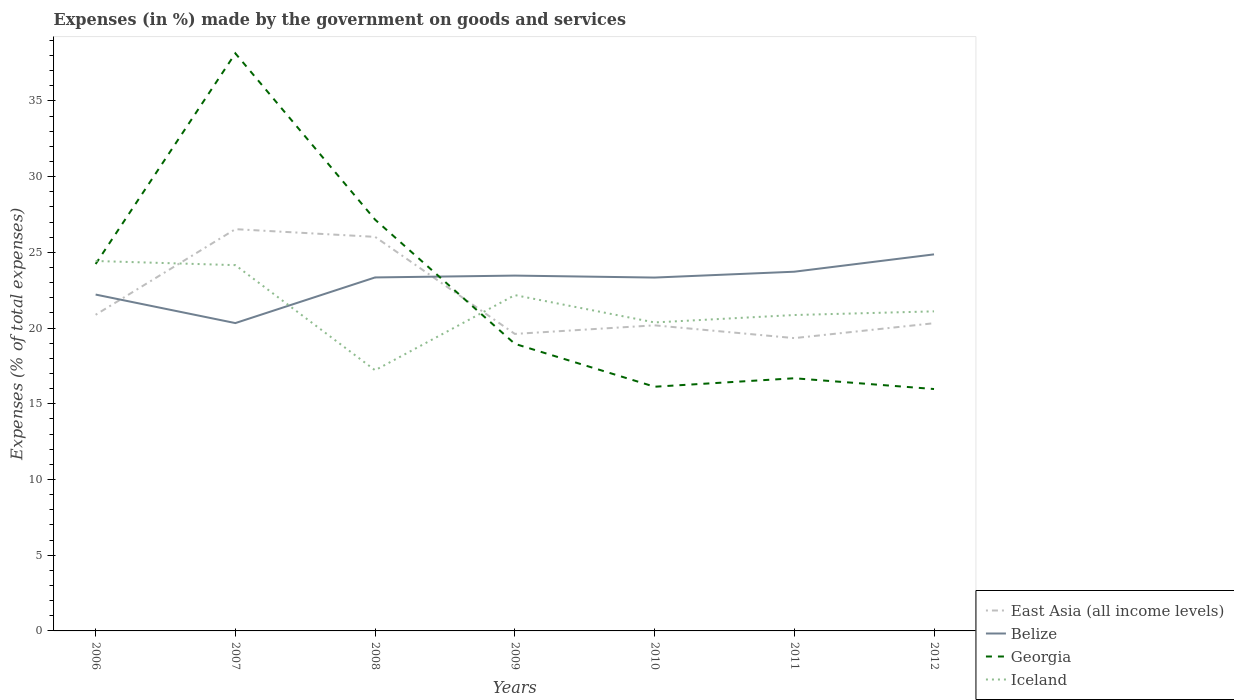How many different coloured lines are there?
Provide a short and direct response. 4. Is the number of lines equal to the number of legend labels?
Your answer should be very brief. Yes. Across all years, what is the maximum percentage of expenses made by the government on goods and services in East Asia (all income levels)?
Offer a terse response. 19.34. In which year was the percentage of expenses made by the government on goods and services in Georgia maximum?
Ensure brevity in your answer.  2012. What is the total percentage of expenses made by the government on goods and services in Belize in the graph?
Your answer should be very brief. -1.51. What is the difference between the highest and the second highest percentage of expenses made by the government on goods and services in East Asia (all income levels)?
Offer a terse response. 7.19. Is the percentage of expenses made by the government on goods and services in Iceland strictly greater than the percentage of expenses made by the government on goods and services in Georgia over the years?
Your response must be concise. No. How many lines are there?
Provide a short and direct response. 4. What is the difference between two consecutive major ticks on the Y-axis?
Keep it short and to the point. 5. Does the graph contain any zero values?
Ensure brevity in your answer.  No. Where does the legend appear in the graph?
Ensure brevity in your answer.  Bottom right. How many legend labels are there?
Your response must be concise. 4. What is the title of the graph?
Offer a terse response. Expenses (in %) made by the government on goods and services. Does "Antigua and Barbuda" appear as one of the legend labels in the graph?
Your answer should be very brief. No. What is the label or title of the Y-axis?
Keep it short and to the point. Expenses (% of total expenses). What is the Expenses (% of total expenses) in East Asia (all income levels) in 2006?
Provide a succinct answer. 20.88. What is the Expenses (% of total expenses) of Belize in 2006?
Your answer should be compact. 22.21. What is the Expenses (% of total expenses) of Georgia in 2006?
Provide a short and direct response. 24.23. What is the Expenses (% of total expenses) of Iceland in 2006?
Your answer should be very brief. 24.43. What is the Expenses (% of total expenses) in East Asia (all income levels) in 2007?
Your answer should be very brief. 26.53. What is the Expenses (% of total expenses) of Belize in 2007?
Your response must be concise. 20.33. What is the Expenses (% of total expenses) in Georgia in 2007?
Provide a succinct answer. 38.14. What is the Expenses (% of total expenses) of Iceland in 2007?
Offer a very short reply. 24.16. What is the Expenses (% of total expenses) in East Asia (all income levels) in 2008?
Ensure brevity in your answer.  26.02. What is the Expenses (% of total expenses) in Belize in 2008?
Your response must be concise. 23.35. What is the Expenses (% of total expenses) in Georgia in 2008?
Offer a very short reply. 27.16. What is the Expenses (% of total expenses) in Iceland in 2008?
Keep it short and to the point. 17.22. What is the Expenses (% of total expenses) of East Asia (all income levels) in 2009?
Make the answer very short. 19.62. What is the Expenses (% of total expenses) of Belize in 2009?
Your response must be concise. 23.47. What is the Expenses (% of total expenses) of Georgia in 2009?
Offer a very short reply. 18.96. What is the Expenses (% of total expenses) of Iceland in 2009?
Provide a short and direct response. 22.18. What is the Expenses (% of total expenses) in East Asia (all income levels) in 2010?
Your answer should be very brief. 20.18. What is the Expenses (% of total expenses) in Belize in 2010?
Provide a succinct answer. 23.34. What is the Expenses (% of total expenses) of Georgia in 2010?
Offer a very short reply. 16.13. What is the Expenses (% of total expenses) of Iceland in 2010?
Give a very brief answer. 20.37. What is the Expenses (% of total expenses) of East Asia (all income levels) in 2011?
Make the answer very short. 19.34. What is the Expenses (% of total expenses) in Belize in 2011?
Offer a very short reply. 23.72. What is the Expenses (% of total expenses) of Georgia in 2011?
Your answer should be compact. 16.69. What is the Expenses (% of total expenses) of Iceland in 2011?
Ensure brevity in your answer.  20.86. What is the Expenses (% of total expenses) of East Asia (all income levels) in 2012?
Your response must be concise. 20.32. What is the Expenses (% of total expenses) in Belize in 2012?
Give a very brief answer. 24.87. What is the Expenses (% of total expenses) in Georgia in 2012?
Your response must be concise. 15.98. What is the Expenses (% of total expenses) in Iceland in 2012?
Your answer should be compact. 21.11. Across all years, what is the maximum Expenses (% of total expenses) in East Asia (all income levels)?
Offer a very short reply. 26.53. Across all years, what is the maximum Expenses (% of total expenses) of Belize?
Your answer should be very brief. 24.87. Across all years, what is the maximum Expenses (% of total expenses) in Georgia?
Offer a terse response. 38.14. Across all years, what is the maximum Expenses (% of total expenses) of Iceland?
Your response must be concise. 24.43. Across all years, what is the minimum Expenses (% of total expenses) in East Asia (all income levels)?
Provide a short and direct response. 19.34. Across all years, what is the minimum Expenses (% of total expenses) in Belize?
Make the answer very short. 20.33. Across all years, what is the minimum Expenses (% of total expenses) in Georgia?
Offer a very short reply. 15.98. Across all years, what is the minimum Expenses (% of total expenses) of Iceland?
Offer a very short reply. 17.22. What is the total Expenses (% of total expenses) of East Asia (all income levels) in the graph?
Your answer should be compact. 152.89. What is the total Expenses (% of total expenses) in Belize in the graph?
Keep it short and to the point. 161.28. What is the total Expenses (% of total expenses) in Georgia in the graph?
Keep it short and to the point. 157.29. What is the total Expenses (% of total expenses) of Iceland in the graph?
Give a very brief answer. 150.32. What is the difference between the Expenses (% of total expenses) in East Asia (all income levels) in 2006 and that in 2007?
Offer a terse response. -5.65. What is the difference between the Expenses (% of total expenses) in Belize in 2006 and that in 2007?
Your answer should be very brief. 1.88. What is the difference between the Expenses (% of total expenses) in Georgia in 2006 and that in 2007?
Your response must be concise. -13.91. What is the difference between the Expenses (% of total expenses) in Iceland in 2006 and that in 2007?
Provide a succinct answer. 0.27. What is the difference between the Expenses (% of total expenses) of East Asia (all income levels) in 2006 and that in 2008?
Provide a short and direct response. -5.15. What is the difference between the Expenses (% of total expenses) in Belize in 2006 and that in 2008?
Offer a terse response. -1.13. What is the difference between the Expenses (% of total expenses) in Georgia in 2006 and that in 2008?
Provide a succinct answer. -2.93. What is the difference between the Expenses (% of total expenses) in Iceland in 2006 and that in 2008?
Offer a very short reply. 7.22. What is the difference between the Expenses (% of total expenses) of East Asia (all income levels) in 2006 and that in 2009?
Give a very brief answer. 1.26. What is the difference between the Expenses (% of total expenses) of Belize in 2006 and that in 2009?
Make the answer very short. -1.25. What is the difference between the Expenses (% of total expenses) of Georgia in 2006 and that in 2009?
Ensure brevity in your answer.  5.27. What is the difference between the Expenses (% of total expenses) of Iceland in 2006 and that in 2009?
Give a very brief answer. 2.25. What is the difference between the Expenses (% of total expenses) of East Asia (all income levels) in 2006 and that in 2010?
Make the answer very short. 0.7. What is the difference between the Expenses (% of total expenses) of Belize in 2006 and that in 2010?
Provide a short and direct response. -1.12. What is the difference between the Expenses (% of total expenses) of Georgia in 2006 and that in 2010?
Ensure brevity in your answer.  8.1. What is the difference between the Expenses (% of total expenses) in Iceland in 2006 and that in 2010?
Provide a succinct answer. 4.06. What is the difference between the Expenses (% of total expenses) of East Asia (all income levels) in 2006 and that in 2011?
Keep it short and to the point. 1.54. What is the difference between the Expenses (% of total expenses) of Belize in 2006 and that in 2011?
Offer a terse response. -1.51. What is the difference between the Expenses (% of total expenses) of Georgia in 2006 and that in 2011?
Offer a very short reply. 7.54. What is the difference between the Expenses (% of total expenses) in Iceland in 2006 and that in 2011?
Ensure brevity in your answer.  3.57. What is the difference between the Expenses (% of total expenses) in East Asia (all income levels) in 2006 and that in 2012?
Give a very brief answer. 0.56. What is the difference between the Expenses (% of total expenses) in Belize in 2006 and that in 2012?
Offer a very short reply. -2.65. What is the difference between the Expenses (% of total expenses) in Georgia in 2006 and that in 2012?
Offer a very short reply. 8.26. What is the difference between the Expenses (% of total expenses) of Iceland in 2006 and that in 2012?
Your response must be concise. 3.33. What is the difference between the Expenses (% of total expenses) in East Asia (all income levels) in 2007 and that in 2008?
Ensure brevity in your answer.  0.51. What is the difference between the Expenses (% of total expenses) in Belize in 2007 and that in 2008?
Your answer should be compact. -3.01. What is the difference between the Expenses (% of total expenses) in Georgia in 2007 and that in 2008?
Keep it short and to the point. 10.98. What is the difference between the Expenses (% of total expenses) in Iceland in 2007 and that in 2008?
Your answer should be compact. 6.94. What is the difference between the Expenses (% of total expenses) in East Asia (all income levels) in 2007 and that in 2009?
Your response must be concise. 6.92. What is the difference between the Expenses (% of total expenses) in Belize in 2007 and that in 2009?
Ensure brevity in your answer.  -3.14. What is the difference between the Expenses (% of total expenses) in Georgia in 2007 and that in 2009?
Offer a terse response. 19.18. What is the difference between the Expenses (% of total expenses) of Iceland in 2007 and that in 2009?
Make the answer very short. 1.98. What is the difference between the Expenses (% of total expenses) in East Asia (all income levels) in 2007 and that in 2010?
Give a very brief answer. 6.35. What is the difference between the Expenses (% of total expenses) of Belize in 2007 and that in 2010?
Provide a short and direct response. -3.01. What is the difference between the Expenses (% of total expenses) of Georgia in 2007 and that in 2010?
Provide a succinct answer. 22.02. What is the difference between the Expenses (% of total expenses) of Iceland in 2007 and that in 2010?
Your response must be concise. 3.78. What is the difference between the Expenses (% of total expenses) in East Asia (all income levels) in 2007 and that in 2011?
Give a very brief answer. 7.19. What is the difference between the Expenses (% of total expenses) in Belize in 2007 and that in 2011?
Your response must be concise. -3.39. What is the difference between the Expenses (% of total expenses) in Georgia in 2007 and that in 2011?
Ensure brevity in your answer.  21.46. What is the difference between the Expenses (% of total expenses) in Iceland in 2007 and that in 2011?
Your answer should be very brief. 3.29. What is the difference between the Expenses (% of total expenses) in East Asia (all income levels) in 2007 and that in 2012?
Offer a terse response. 6.21. What is the difference between the Expenses (% of total expenses) in Belize in 2007 and that in 2012?
Your response must be concise. -4.54. What is the difference between the Expenses (% of total expenses) of Georgia in 2007 and that in 2012?
Offer a very short reply. 22.17. What is the difference between the Expenses (% of total expenses) in Iceland in 2007 and that in 2012?
Your response must be concise. 3.05. What is the difference between the Expenses (% of total expenses) in East Asia (all income levels) in 2008 and that in 2009?
Provide a succinct answer. 6.41. What is the difference between the Expenses (% of total expenses) of Belize in 2008 and that in 2009?
Provide a succinct answer. -0.12. What is the difference between the Expenses (% of total expenses) in Georgia in 2008 and that in 2009?
Offer a very short reply. 8.2. What is the difference between the Expenses (% of total expenses) in Iceland in 2008 and that in 2009?
Keep it short and to the point. -4.96. What is the difference between the Expenses (% of total expenses) of East Asia (all income levels) in 2008 and that in 2010?
Provide a succinct answer. 5.84. What is the difference between the Expenses (% of total expenses) of Belize in 2008 and that in 2010?
Provide a succinct answer. 0.01. What is the difference between the Expenses (% of total expenses) in Georgia in 2008 and that in 2010?
Your response must be concise. 11.03. What is the difference between the Expenses (% of total expenses) of Iceland in 2008 and that in 2010?
Make the answer very short. -3.16. What is the difference between the Expenses (% of total expenses) in East Asia (all income levels) in 2008 and that in 2011?
Ensure brevity in your answer.  6.69. What is the difference between the Expenses (% of total expenses) of Belize in 2008 and that in 2011?
Your answer should be compact. -0.38. What is the difference between the Expenses (% of total expenses) in Georgia in 2008 and that in 2011?
Offer a very short reply. 10.47. What is the difference between the Expenses (% of total expenses) in Iceland in 2008 and that in 2011?
Your response must be concise. -3.65. What is the difference between the Expenses (% of total expenses) of East Asia (all income levels) in 2008 and that in 2012?
Provide a succinct answer. 5.7. What is the difference between the Expenses (% of total expenses) in Belize in 2008 and that in 2012?
Your response must be concise. -1.52. What is the difference between the Expenses (% of total expenses) in Georgia in 2008 and that in 2012?
Ensure brevity in your answer.  11.19. What is the difference between the Expenses (% of total expenses) in Iceland in 2008 and that in 2012?
Give a very brief answer. -3.89. What is the difference between the Expenses (% of total expenses) in East Asia (all income levels) in 2009 and that in 2010?
Ensure brevity in your answer.  -0.57. What is the difference between the Expenses (% of total expenses) of Belize in 2009 and that in 2010?
Give a very brief answer. 0.13. What is the difference between the Expenses (% of total expenses) of Georgia in 2009 and that in 2010?
Ensure brevity in your answer.  2.83. What is the difference between the Expenses (% of total expenses) in Iceland in 2009 and that in 2010?
Your answer should be compact. 1.8. What is the difference between the Expenses (% of total expenses) of East Asia (all income levels) in 2009 and that in 2011?
Make the answer very short. 0.28. What is the difference between the Expenses (% of total expenses) in Belize in 2009 and that in 2011?
Your response must be concise. -0.26. What is the difference between the Expenses (% of total expenses) of Georgia in 2009 and that in 2011?
Your answer should be compact. 2.27. What is the difference between the Expenses (% of total expenses) in Iceland in 2009 and that in 2011?
Offer a very short reply. 1.32. What is the difference between the Expenses (% of total expenses) in East Asia (all income levels) in 2009 and that in 2012?
Keep it short and to the point. -0.71. What is the difference between the Expenses (% of total expenses) of Belize in 2009 and that in 2012?
Offer a terse response. -1.4. What is the difference between the Expenses (% of total expenses) in Georgia in 2009 and that in 2012?
Offer a very short reply. 2.98. What is the difference between the Expenses (% of total expenses) in Iceland in 2009 and that in 2012?
Make the answer very short. 1.07. What is the difference between the Expenses (% of total expenses) in East Asia (all income levels) in 2010 and that in 2011?
Ensure brevity in your answer.  0.84. What is the difference between the Expenses (% of total expenses) in Belize in 2010 and that in 2011?
Provide a succinct answer. -0.39. What is the difference between the Expenses (% of total expenses) of Georgia in 2010 and that in 2011?
Provide a succinct answer. -0.56. What is the difference between the Expenses (% of total expenses) of Iceland in 2010 and that in 2011?
Your answer should be very brief. -0.49. What is the difference between the Expenses (% of total expenses) in East Asia (all income levels) in 2010 and that in 2012?
Provide a succinct answer. -0.14. What is the difference between the Expenses (% of total expenses) of Belize in 2010 and that in 2012?
Your answer should be compact. -1.53. What is the difference between the Expenses (% of total expenses) in Georgia in 2010 and that in 2012?
Your response must be concise. 0.15. What is the difference between the Expenses (% of total expenses) of Iceland in 2010 and that in 2012?
Provide a succinct answer. -0.73. What is the difference between the Expenses (% of total expenses) in East Asia (all income levels) in 2011 and that in 2012?
Offer a very short reply. -0.98. What is the difference between the Expenses (% of total expenses) of Belize in 2011 and that in 2012?
Make the answer very short. -1.15. What is the difference between the Expenses (% of total expenses) in Georgia in 2011 and that in 2012?
Ensure brevity in your answer.  0.71. What is the difference between the Expenses (% of total expenses) of Iceland in 2011 and that in 2012?
Provide a succinct answer. -0.24. What is the difference between the Expenses (% of total expenses) in East Asia (all income levels) in 2006 and the Expenses (% of total expenses) in Belize in 2007?
Your answer should be compact. 0.55. What is the difference between the Expenses (% of total expenses) of East Asia (all income levels) in 2006 and the Expenses (% of total expenses) of Georgia in 2007?
Ensure brevity in your answer.  -17.27. What is the difference between the Expenses (% of total expenses) in East Asia (all income levels) in 2006 and the Expenses (% of total expenses) in Iceland in 2007?
Provide a succinct answer. -3.28. What is the difference between the Expenses (% of total expenses) of Belize in 2006 and the Expenses (% of total expenses) of Georgia in 2007?
Make the answer very short. -15.93. What is the difference between the Expenses (% of total expenses) in Belize in 2006 and the Expenses (% of total expenses) in Iceland in 2007?
Offer a terse response. -1.94. What is the difference between the Expenses (% of total expenses) in Georgia in 2006 and the Expenses (% of total expenses) in Iceland in 2007?
Provide a short and direct response. 0.07. What is the difference between the Expenses (% of total expenses) of East Asia (all income levels) in 2006 and the Expenses (% of total expenses) of Belize in 2008?
Your response must be concise. -2.47. What is the difference between the Expenses (% of total expenses) of East Asia (all income levels) in 2006 and the Expenses (% of total expenses) of Georgia in 2008?
Keep it short and to the point. -6.28. What is the difference between the Expenses (% of total expenses) in East Asia (all income levels) in 2006 and the Expenses (% of total expenses) in Iceland in 2008?
Offer a terse response. 3.66. What is the difference between the Expenses (% of total expenses) in Belize in 2006 and the Expenses (% of total expenses) in Georgia in 2008?
Your answer should be very brief. -4.95. What is the difference between the Expenses (% of total expenses) in Belize in 2006 and the Expenses (% of total expenses) in Iceland in 2008?
Your answer should be very brief. 5. What is the difference between the Expenses (% of total expenses) in Georgia in 2006 and the Expenses (% of total expenses) in Iceland in 2008?
Offer a very short reply. 7.02. What is the difference between the Expenses (% of total expenses) in East Asia (all income levels) in 2006 and the Expenses (% of total expenses) in Belize in 2009?
Offer a very short reply. -2.59. What is the difference between the Expenses (% of total expenses) in East Asia (all income levels) in 2006 and the Expenses (% of total expenses) in Georgia in 2009?
Keep it short and to the point. 1.92. What is the difference between the Expenses (% of total expenses) in East Asia (all income levels) in 2006 and the Expenses (% of total expenses) in Iceland in 2009?
Your answer should be very brief. -1.3. What is the difference between the Expenses (% of total expenses) in Belize in 2006 and the Expenses (% of total expenses) in Georgia in 2009?
Your response must be concise. 3.25. What is the difference between the Expenses (% of total expenses) of Belize in 2006 and the Expenses (% of total expenses) of Iceland in 2009?
Your answer should be compact. 0.04. What is the difference between the Expenses (% of total expenses) of Georgia in 2006 and the Expenses (% of total expenses) of Iceland in 2009?
Provide a short and direct response. 2.05. What is the difference between the Expenses (% of total expenses) in East Asia (all income levels) in 2006 and the Expenses (% of total expenses) in Belize in 2010?
Offer a terse response. -2.46. What is the difference between the Expenses (% of total expenses) in East Asia (all income levels) in 2006 and the Expenses (% of total expenses) in Georgia in 2010?
Make the answer very short. 4.75. What is the difference between the Expenses (% of total expenses) of East Asia (all income levels) in 2006 and the Expenses (% of total expenses) of Iceland in 2010?
Ensure brevity in your answer.  0.51. What is the difference between the Expenses (% of total expenses) in Belize in 2006 and the Expenses (% of total expenses) in Georgia in 2010?
Make the answer very short. 6.09. What is the difference between the Expenses (% of total expenses) in Belize in 2006 and the Expenses (% of total expenses) in Iceland in 2010?
Provide a succinct answer. 1.84. What is the difference between the Expenses (% of total expenses) of Georgia in 2006 and the Expenses (% of total expenses) of Iceland in 2010?
Your response must be concise. 3.86. What is the difference between the Expenses (% of total expenses) in East Asia (all income levels) in 2006 and the Expenses (% of total expenses) in Belize in 2011?
Your response must be concise. -2.84. What is the difference between the Expenses (% of total expenses) in East Asia (all income levels) in 2006 and the Expenses (% of total expenses) in Georgia in 2011?
Keep it short and to the point. 4.19. What is the difference between the Expenses (% of total expenses) of East Asia (all income levels) in 2006 and the Expenses (% of total expenses) of Iceland in 2011?
Make the answer very short. 0.02. What is the difference between the Expenses (% of total expenses) in Belize in 2006 and the Expenses (% of total expenses) in Georgia in 2011?
Give a very brief answer. 5.53. What is the difference between the Expenses (% of total expenses) in Belize in 2006 and the Expenses (% of total expenses) in Iceland in 2011?
Offer a terse response. 1.35. What is the difference between the Expenses (% of total expenses) of Georgia in 2006 and the Expenses (% of total expenses) of Iceland in 2011?
Keep it short and to the point. 3.37. What is the difference between the Expenses (% of total expenses) of East Asia (all income levels) in 2006 and the Expenses (% of total expenses) of Belize in 2012?
Keep it short and to the point. -3.99. What is the difference between the Expenses (% of total expenses) in East Asia (all income levels) in 2006 and the Expenses (% of total expenses) in Georgia in 2012?
Keep it short and to the point. 4.9. What is the difference between the Expenses (% of total expenses) of East Asia (all income levels) in 2006 and the Expenses (% of total expenses) of Iceland in 2012?
Offer a very short reply. -0.23. What is the difference between the Expenses (% of total expenses) of Belize in 2006 and the Expenses (% of total expenses) of Georgia in 2012?
Make the answer very short. 6.24. What is the difference between the Expenses (% of total expenses) of Belize in 2006 and the Expenses (% of total expenses) of Iceland in 2012?
Make the answer very short. 1.11. What is the difference between the Expenses (% of total expenses) in Georgia in 2006 and the Expenses (% of total expenses) in Iceland in 2012?
Offer a terse response. 3.13. What is the difference between the Expenses (% of total expenses) of East Asia (all income levels) in 2007 and the Expenses (% of total expenses) of Belize in 2008?
Offer a very short reply. 3.19. What is the difference between the Expenses (% of total expenses) in East Asia (all income levels) in 2007 and the Expenses (% of total expenses) in Georgia in 2008?
Provide a short and direct response. -0.63. What is the difference between the Expenses (% of total expenses) of East Asia (all income levels) in 2007 and the Expenses (% of total expenses) of Iceland in 2008?
Offer a terse response. 9.32. What is the difference between the Expenses (% of total expenses) of Belize in 2007 and the Expenses (% of total expenses) of Georgia in 2008?
Your response must be concise. -6.83. What is the difference between the Expenses (% of total expenses) of Belize in 2007 and the Expenses (% of total expenses) of Iceland in 2008?
Offer a very short reply. 3.12. What is the difference between the Expenses (% of total expenses) of Georgia in 2007 and the Expenses (% of total expenses) of Iceland in 2008?
Keep it short and to the point. 20.93. What is the difference between the Expenses (% of total expenses) in East Asia (all income levels) in 2007 and the Expenses (% of total expenses) in Belize in 2009?
Keep it short and to the point. 3.07. What is the difference between the Expenses (% of total expenses) of East Asia (all income levels) in 2007 and the Expenses (% of total expenses) of Georgia in 2009?
Your answer should be compact. 7.57. What is the difference between the Expenses (% of total expenses) in East Asia (all income levels) in 2007 and the Expenses (% of total expenses) in Iceland in 2009?
Provide a short and direct response. 4.36. What is the difference between the Expenses (% of total expenses) in Belize in 2007 and the Expenses (% of total expenses) in Georgia in 2009?
Provide a succinct answer. 1.37. What is the difference between the Expenses (% of total expenses) in Belize in 2007 and the Expenses (% of total expenses) in Iceland in 2009?
Your answer should be very brief. -1.85. What is the difference between the Expenses (% of total expenses) in Georgia in 2007 and the Expenses (% of total expenses) in Iceland in 2009?
Your answer should be very brief. 15.97. What is the difference between the Expenses (% of total expenses) in East Asia (all income levels) in 2007 and the Expenses (% of total expenses) in Belize in 2010?
Provide a short and direct response. 3.2. What is the difference between the Expenses (% of total expenses) in East Asia (all income levels) in 2007 and the Expenses (% of total expenses) in Georgia in 2010?
Keep it short and to the point. 10.41. What is the difference between the Expenses (% of total expenses) in East Asia (all income levels) in 2007 and the Expenses (% of total expenses) in Iceland in 2010?
Provide a succinct answer. 6.16. What is the difference between the Expenses (% of total expenses) of Belize in 2007 and the Expenses (% of total expenses) of Georgia in 2010?
Ensure brevity in your answer.  4.2. What is the difference between the Expenses (% of total expenses) in Belize in 2007 and the Expenses (% of total expenses) in Iceland in 2010?
Your answer should be very brief. -0.04. What is the difference between the Expenses (% of total expenses) of Georgia in 2007 and the Expenses (% of total expenses) of Iceland in 2010?
Your answer should be very brief. 17.77. What is the difference between the Expenses (% of total expenses) in East Asia (all income levels) in 2007 and the Expenses (% of total expenses) in Belize in 2011?
Provide a short and direct response. 2.81. What is the difference between the Expenses (% of total expenses) in East Asia (all income levels) in 2007 and the Expenses (% of total expenses) in Georgia in 2011?
Your response must be concise. 9.85. What is the difference between the Expenses (% of total expenses) of East Asia (all income levels) in 2007 and the Expenses (% of total expenses) of Iceland in 2011?
Your answer should be compact. 5.67. What is the difference between the Expenses (% of total expenses) in Belize in 2007 and the Expenses (% of total expenses) in Georgia in 2011?
Your answer should be compact. 3.64. What is the difference between the Expenses (% of total expenses) in Belize in 2007 and the Expenses (% of total expenses) in Iceland in 2011?
Ensure brevity in your answer.  -0.53. What is the difference between the Expenses (% of total expenses) of Georgia in 2007 and the Expenses (% of total expenses) of Iceland in 2011?
Offer a very short reply. 17.28. What is the difference between the Expenses (% of total expenses) in East Asia (all income levels) in 2007 and the Expenses (% of total expenses) in Belize in 2012?
Offer a very short reply. 1.66. What is the difference between the Expenses (% of total expenses) in East Asia (all income levels) in 2007 and the Expenses (% of total expenses) in Georgia in 2012?
Give a very brief answer. 10.56. What is the difference between the Expenses (% of total expenses) in East Asia (all income levels) in 2007 and the Expenses (% of total expenses) in Iceland in 2012?
Your answer should be very brief. 5.43. What is the difference between the Expenses (% of total expenses) in Belize in 2007 and the Expenses (% of total expenses) in Georgia in 2012?
Your answer should be very brief. 4.36. What is the difference between the Expenses (% of total expenses) in Belize in 2007 and the Expenses (% of total expenses) in Iceland in 2012?
Keep it short and to the point. -0.77. What is the difference between the Expenses (% of total expenses) of Georgia in 2007 and the Expenses (% of total expenses) of Iceland in 2012?
Give a very brief answer. 17.04. What is the difference between the Expenses (% of total expenses) of East Asia (all income levels) in 2008 and the Expenses (% of total expenses) of Belize in 2009?
Keep it short and to the point. 2.56. What is the difference between the Expenses (% of total expenses) of East Asia (all income levels) in 2008 and the Expenses (% of total expenses) of Georgia in 2009?
Provide a short and direct response. 7.06. What is the difference between the Expenses (% of total expenses) in East Asia (all income levels) in 2008 and the Expenses (% of total expenses) in Iceland in 2009?
Ensure brevity in your answer.  3.85. What is the difference between the Expenses (% of total expenses) in Belize in 2008 and the Expenses (% of total expenses) in Georgia in 2009?
Offer a terse response. 4.38. What is the difference between the Expenses (% of total expenses) in Belize in 2008 and the Expenses (% of total expenses) in Iceland in 2009?
Give a very brief answer. 1.17. What is the difference between the Expenses (% of total expenses) of Georgia in 2008 and the Expenses (% of total expenses) of Iceland in 2009?
Your response must be concise. 4.98. What is the difference between the Expenses (% of total expenses) in East Asia (all income levels) in 2008 and the Expenses (% of total expenses) in Belize in 2010?
Ensure brevity in your answer.  2.69. What is the difference between the Expenses (% of total expenses) in East Asia (all income levels) in 2008 and the Expenses (% of total expenses) in Georgia in 2010?
Provide a succinct answer. 9.9. What is the difference between the Expenses (% of total expenses) in East Asia (all income levels) in 2008 and the Expenses (% of total expenses) in Iceland in 2010?
Make the answer very short. 5.65. What is the difference between the Expenses (% of total expenses) in Belize in 2008 and the Expenses (% of total expenses) in Georgia in 2010?
Provide a succinct answer. 7.22. What is the difference between the Expenses (% of total expenses) in Belize in 2008 and the Expenses (% of total expenses) in Iceland in 2010?
Your answer should be compact. 2.97. What is the difference between the Expenses (% of total expenses) of Georgia in 2008 and the Expenses (% of total expenses) of Iceland in 2010?
Your response must be concise. 6.79. What is the difference between the Expenses (% of total expenses) of East Asia (all income levels) in 2008 and the Expenses (% of total expenses) of Belize in 2011?
Provide a short and direct response. 2.3. What is the difference between the Expenses (% of total expenses) in East Asia (all income levels) in 2008 and the Expenses (% of total expenses) in Georgia in 2011?
Offer a terse response. 9.34. What is the difference between the Expenses (% of total expenses) of East Asia (all income levels) in 2008 and the Expenses (% of total expenses) of Iceland in 2011?
Offer a very short reply. 5.16. What is the difference between the Expenses (% of total expenses) of Belize in 2008 and the Expenses (% of total expenses) of Georgia in 2011?
Provide a short and direct response. 6.66. What is the difference between the Expenses (% of total expenses) of Belize in 2008 and the Expenses (% of total expenses) of Iceland in 2011?
Ensure brevity in your answer.  2.48. What is the difference between the Expenses (% of total expenses) in Georgia in 2008 and the Expenses (% of total expenses) in Iceland in 2011?
Your answer should be very brief. 6.3. What is the difference between the Expenses (% of total expenses) in East Asia (all income levels) in 2008 and the Expenses (% of total expenses) in Belize in 2012?
Provide a short and direct response. 1.16. What is the difference between the Expenses (% of total expenses) in East Asia (all income levels) in 2008 and the Expenses (% of total expenses) in Georgia in 2012?
Keep it short and to the point. 10.05. What is the difference between the Expenses (% of total expenses) of East Asia (all income levels) in 2008 and the Expenses (% of total expenses) of Iceland in 2012?
Offer a very short reply. 4.92. What is the difference between the Expenses (% of total expenses) in Belize in 2008 and the Expenses (% of total expenses) in Georgia in 2012?
Offer a terse response. 7.37. What is the difference between the Expenses (% of total expenses) in Belize in 2008 and the Expenses (% of total expenses) in Iceland in 2012?
Your response must be concise. 2.24. What is the difference between the Expenses (% of total expenses) of Georgia in 2008 and the Expenses (% of total expenses) of Iceland in 2012?
Give a very brief answer. 6.06. What is the difference between the Expenses (% of total expenses) of East Asia (all income levels) in 2009 and the Expenses (% of total expenses) of Belize in 2010?
Give a very brief answer. -3.72. What is the difference between the Expenses (% of total expenses) of East Asia (all income levels) in 2009 and the Expenses (% of total expenses) of Georgia in 2010?
Your response must be concise. 3.49. What is the difference between the Expenses (% of total expenses) of East Asia (all income levels) in 2009 and the Expenses (% of total expenses) of Iceland in 2010?
Give a very brief answer. -0.76. What is the difference between the Expenses (% of total expenses) in Belize in 2009 and the Expenses (% of total expenses) in Georgia in 2010?
Your response must be concise. 7.34. What is the difference between the Expenses (% of total expenses) of Belize in 2009 and the Expenses (% of total expenses) of Iceland in 2010?
Provide a succinct answer. 3.09. What is the difference between the Expenses (% of total expenses) in Georgia in 2009 and the Expenses (% of total expenses) in Iceland in 2010?
Your response must be concise. -1.41. What is the difference between the Expenses (% of total expenses) of East Asia (all income levels) in 2009 and the Expenses (% of total expenses) of Belize in 2011?
Keep it short and to the point. -4.11. What is the difference between the Expenses (% of total expenses) of East Asia (all income levels) in 2009 and the Expenses (% of total expenses) of Georgia in 2011?
Offer a very short reply. 2.93. What is the difference between the Expenses (% of total expenses) in East Asia (all income levels) in 2009 and the Expenses (% of total expenses) in Iceland in 2011?
Your response must be concise. -1.25. What is the difference between the Expenses (% of total expenses) of Belize in 2009 and the Expenses (% of total expenses) of Georgia in 2011?
Provide a short and direct response. 6.78. What is the difference between the Expenses (% of total expenses) in Belize in 2009 and the Expenses (% of total expenses) in Iceland in 2011?
Offer a very short reply. 2.6. What is the difference between the Expenses (% of total expenses) of Georgia in 2009 and the Expenses (% of total expenses) of Iceland in 2011?
Give a very brief answer. -1.9. What is the difference between the Expenses (% of total expenses) of East Asia (all income levels) in 2009 and the Expenses (% of total expenses) of Belize in 2012?
Give a very brief answer. -5.25. What is the difference between the Expenses (% of total expenses) of East Asia (all income levels) in 2009 and the Expenses (% of total expenses) of Georgia in 2012?
Your answer should be very brief. 3.64. What is the difference between the Expenses (% of total expenses) of East Asia (all income levels) in 2009 and the Expenses (% of total expenses) of Iceland in 2012?
Provide a short and direct response. -1.49. What is the difference between the Expenses (% of total expenses) of Belize in 2009 and the Expenses (% of total expenses) of Georgia in 2012?
Offer a very short reply. 7.49. What is the difference between the Expenses (% of total expenses) of Belize in 2009 and the Expenses (% of total expenses) of Iceland in 2012?
Provide a short and direct response. 2.36. What is the difference between the Expenses (% of total expenses) of Georgia in 2009 and the Expenses (% of total expenses) of Iceland in 2012?
Ensure brevity in your answer.  -2.14. What is the difference between the Expenses (% of total expenses) of East Asia (all income levels) in 2010 and the Expenses (% of total expenses) of Belize in 2011?
Provide a short and direct response. -3.54. What is the difference between the Expenses (% of total expenses) of East Asia (all income levels) in 2010 and the Expenses (% of total expenses) of Georgia in 2011?
Your answer should be compact. 3.5. What is the difference between the Expenses (% of total expenses) in East Asia (all income levels) in 2010 and the Expenses (% of total expenses) in Iceland in 2011?
Ensure brevity in your answer.  -0.68. What is the difference between the Expenses (% of total expenses) of Belize in 2010 and the Expenses (% of total expenses) of Georgia in 2011?
Provide a succinct answer. 6.65. What is the difference between the Expenses (% of total expenses) of Belize in 2010 and the Expenses (% of total expenses) of Iceland in 2011?
Provide a short and direct response. 2.47. What is the difference between the Expenses (% of total expenses) of Georgia in 2010 and the Expenses (% of total expenses) of Iceland in 2011?
Make the answer very short. -4.74. What is the difference between the Expenses (% of total expenses) of East Asia (all income levels) in 2010 and the Expenses (% of total expenses) of Belize in 2012?
Your answer should be very brief. -4.69. What is the difference between the Expenses (% of total expenses) in East Asia (all income levels) in 2010 and the Expenses (% of total expenses) in Georgia in 2012?
Provide a succinct answer. 4.21. What is the difference between the Expenses (% of total expenses) of East Asia (all income levels) in 2010 and the Expenses (% of total expenses) of Iceland in 2012?
Keep it short and to the point. -0.92. What is the difference between the Expenses (% of total expenses) in Belize in 2010 and the Expenses (% of total expenses) in Georgia in 2012?
Your answer should be compact. 7.36. What is the difference between the Expenses (% of total expenses) of Belize in 2010 and the Expenses (% of total expenses) of Iceland in 2012?
Your answer should be compact. 2.23. What is the difference between the Expenses (% of total expenses) of Georgia in 2010 and the Expenses (% of total expenses) of Iceland in 2012?
Offer a terse response. -4.98. What is the difference between the Expenses (% of total expenses) of East Asia (all income levels) in 2011 and the Expenses (% of total expenses) of Belize in 2012?
Make the answer very short. -5.53. What is the difference between the Expenses (% of total expenses) of East Asia (all income levels) in 2011 and the Expenses (% of total expenses) of Georgia in 2012?
Make the answer very short. 3.36. What is the difference between the Expenses (% of total expenses) of East Asia (all income levels) in 2011 and the Expenses (% of total expenses) of Iceland in 2012?
Make the answer very short. -1.77. What is the difference between the Expenses (% of total expenses) in Belize in 2011 and the Expenses (% of total expenses) in Georgia in 2012?
Your answer should be very brief. 7.75. What is the difference between the Expenses (% of total expenses) in Belize in 2011 and the Expenses (% of total expenses) in Iceland in 2012?
Provide a short and direct response. 2.62. What is the difference between the Expenses (% of total expenses) in Georgia in 2011 and the Expenses (% of total expenses) in Iceland in 2012?
Keep it short and to the point. -4.42. What is the average Expenses (% of total expenses) of East Asia (all income levels) per year?
Offer a very short reply. 21.84. What is the average Expenses (% of total expenses) in Belize per year?
Offer a very short reply. 23.04. What is the average Expenses (% of total expenses) of Georgia per year?
Provide a succinct answer. 22.47. What is the average Expenses (% of total expenses) in Iceland per year?
Keep it short and to the point. 21.47. In the year 2006, what is the difference between the Expenses (% of total expenses) of East Asia (all income levels) and Expenses (% of total expenses) of Belize?
Keep it short and to the point. -1.34. In the year 2006, what is the difference between the Expenses (% of total expenses) of East Asia (all income levels) and Expenses (% of total expenses) of Georgia?
Provide a short and direct response. -3.35. In the year 2006, what is the difference between the Expenses (% of total expenses) in East Asia (all income levels) and Expenses (% of total expenses) in Iceland?
Provide a succinct answer. -3.55. In the year 2006, what is the difference between the Expenses (% of total expenses) in Belize and Expenses (% of total expenses) in Georgia?
Offer a very short reply. -2.02. In the year 2006, what is the difference between the Expenses (% of total expenses) in Belize and Expenses (% of total expenses) in Iceland?
Your answer should be very brief. -2.22. In the year 2006, what is the difference between the Expenses (% of total expenses) in Georgia and Expenses (% of total expenses) in Iceland?
Your answer should be very brief. -0.2. In the year 2007, what is the difference between the Expenses (% of total expenses) in East Asia (all income levels) and Expenses (% of total expenses) in Belize?
Your answer should be compact. 6.2. In the year 2007, what is the difference between the Expenses (% of total expenses) of East Asia (all income levels) and Expenses (% of total expenses) of Georgia?
Make the answer very short. -11.61. In the year 2007, what is the difference between the Expenses (% of total expenses) of East Asia (all income levels) and Expenses (% of total expenses) of Iceland?
Keep it short and to the point. 2.38. In the year 2007, what is the difference between the Expenses (% of total expenses) of Belize and Expenses (% of total expenses) of Georgia?
Your response must be concise. -17.81. In the year 2007, what is the difference between the Expenses (% of total expenses) of Belize and Expenses (% of total expenses) of Iceland?
Keep it short and to the point. -3.83. In the year 2007, what is the difference between the Expenses (% of total expenses) in Georgia and Expenses (% of total expenses) in Iceland?
Keep it short and to the point. 13.99. In the year 2008, what is the difference between the Expenses (% of total expenses) in East Asia (all income levels) and Expenses (% of total expenses) in Belize?
Ensure brevity in your answer.  2.68. In the year 2008, what is the difference between the Expenses (% of total expenses) of East Asia (all income levels) and Expenses (% of total expenses) of Georgia?
Your response must be concise. -1.14. In the year 2008, what is the difference between the Expenses (% of total expenses) in East Asia (all income levels) and Expenses (% of total expenses) in Iceland?
Give a very brief answer. 8.81. In the year 2008, what is the difference between the Expenses (% of total expenses) in Belize and Expenses (% of total expenses) in Georgia?
Your response must be concise. -3.82. In the year 2008, what is the difference between the Expenses (% of total expenses) in Belize and Expenses (% of total expenses) in Iceland?
Offer a very short reply. 6.13. In the year 2008, what is the difference between the Expenses (% of total expenses) of Georgia and Expenses (% of total expenses) of Iceland?
Offer a terse response. 9.95. In the year 2009, what is the difference between the Expenses (% of total expenses) in East Asia (all income levels) and Expenses (% of total expenses) in Belize?
Ensure brevity in your answer.  -3.85. In the year 2009, what is the difference between the Expenses (% of total expenses) of East Asia (all income levels) and Expenses (% of total expenses) of Georgia?
Ensure brevity in your answer.  0.65. In the year 2009, what is the difference between the Expenses (% of total expenses) in East Asia (all income levels) and Expenses (% of total expenses) in Iceland?
Your answer should be compact. -2.56. In the year 2009, what is the difference between the Expenses (% of total expenses) in Belize and Expenses (% of total expenses) in Georgia?
Give a very brief answer. 4.51. In the year 2009, what is the difference between the Expenses (% of total expenses) of Belize and Expenses (% of total expenses) of Iceland?
Ensure brevity in your answer.  1.29. In the year 2009, what is the difference between the Expenses (% of total expenses) of Georgia and Expenses (% of total expenses) of Iceland?
Ensure brevity in your answer.  -3.22. In the year 2010, what is the difference between the Expenses (% of total expenses) of East Asia (all income levels) and Expenses (% of total expenses) of Belize?
Ensure brevity in your answer.  -3.15. In the year 2010, what is the difference between the Expenses (% of total expenses) of East Asia (all income levels) and Expenses (% of total expenses) of Georgia?
Ensure brevity in your answer.  4.05. In the year 2010, what is the difference between the Expenses (% of total expenses) in East Asia (all income levels) and Expenses (% of total expenses) in Iceland?
Offer a very short reply. -0.19. In the year 2010, what is the difference between the Expenses (% of total expenses) of Belize and Expenses (% of total expenses) of Georgia?
Make the answer very short. 7.21. In the year 2010, what is the difference between the Expenses (% of total expenses) of Belize and Expenses (% of total expenses) of Iceland?
Keep it short and to the point. 2.96. In the year 2010, what is the difference between the Expenses (% of total expenses) of Georgia and Expenses (% of total expenses) of Iceland?
Offer a very short reply. -4.25. In the year 2011, what is the difference between the Expenses (% of total expenses) in East Asia (all income levels) and Expenses (% of total expenses) in Belize?
Your answer should be very brief. -4.38. In the year 2011, what is the difference between the Expenses (% of total expenses) of East Asia (all income levels) and Expenses (% of total expenses) of Georgia?
Offer a terse response. 2.65. In the year 2011, what is the difference between the Expenses (% of total expenses) in East Asia (all income levels) and Expenses (% of total expenses) in Iceland?
Ensure brevity in your answer.  -1.52. In the year 2011, what is the difference between the Expenses (% of total expenses) of Belize and Expenses (% of total expenses) of Georgia?
Give a very brief answer. 7.04. In the year 2011, what is the difference between the Expenses (% of total expenses) in Belize and Expenses (% of total expenses) in Iceland?
Give a very brief answer. 2.86. In the year 2011, what is the difference between the Expenses (% of total expenses) of Georgia and Expenses (% of total expenses) of Iceland?
Offer a very short reply. -4.18. In the year 2012, what is the difference between the Expenses (% of total expenses) of East Asia (all income levels) and Expenses (% of total expenses) of Belize?
Your answer should be very brief. -4.55. In the year 2012, what is the difference between the Expenses (% of total expenses) of East Asia (all income levels) and Expenses (% of total expenses) of Georgia?
Provide a succinct answer. 4.35. In the year 2012, what is the difference between the Expenses (% of total expenses) of East Asia (all income levels) and Expenses (% of total expenses) of Iceland?
Your response must be concise. -0.78. In the year 2012, what is the difference between the Expenses (% of total expenses) of Belize and Expenses (% of total expenses) of Georgia?
Your answer should be very brief. 8.89. In the year 2012, what is the difference between the Expenses (% of total expenses) of Belize and Expenses (% of total expenses) of Iceland?
Your response must be concise. 3.76. In the year 2012, what is the difference between the Expenses (% of total expenses) of Georgia and Expenses (% of total expenses) of Iceland?
Keep it short and to the point. -5.13. What is the ratio of the Expenses (% of total expenses) of East Asia (all income levels) in 2006 to that in 2007?
Provide a short and direct response. 0.79. What is the ratio of the Expenses (% of total expenses) of Belize in 2006 to that in 2007?
Offer a very short reply. 1.09. What is the ratio of the Expenses (% of total expenses) of Georgia in 2006 to that in 2007?
Offer a terse response. 0.64. What is the ratio of the Expenses (% of total expenses) in Iceland in 2006 to that in 2007?
Make the answer very short. 1.01. What is the ratio of the Expenses (% of total expenses) in East Asia (all income levels) in 2006 to that in 2008?
Your response must be concise. 0.8. What is the ratio of the Expenses (% of total expenses) in Belize in 2006 to that in 2008?
Your answer should be compact. 0.95. What is the ratio of the Expenses (% of total expenses) of Georgia in 2006 to that in 2008?
Ensure brevity in your answer.  0.89. What is the ratio of the Expenses (% of total expenses) of Iceland in 2006 to that in 2008?
Keep it short and to the point. 1.42. What is the ratio of the Expenses (% of total expenses) of East Asia (all income levels) in 2006 to that in 2009?
Offer a very short reply. 1.06. What is the ratio of the Expenses (% of total expenses) of Belize in 2006 to that in 2009?
Ensure brevity in your answer.  0.95. What is the ratio of the Expenses (% of total expenses) of Georgia in 2006 to that in 2009?
Offer a very short reply. 1.28. What is the ratio of the Expenses (% of total expenses) of Iceland in 2006 to that in 2009?
Your answer should be very brief. 1.1. What is the ratio of the Expenses (% of total expenses) of East Asia (all income levels) in 2006 to that in 2010?
Your response must be concise. 1.03. What is the ratio of the Expenses (% of total expenses) in Belize in 2006 to that in 2010?
Provide a short and direct response. 0.95. What is the ratio of the Expenses (% of total expenses) of Georgia in 2006 to that in 2010?
Your response must be concise. 1.5. What is the ratio of the Expenses (% of total expenses) of Iceland in 2006 to that in 2010?
Offer a very short reply. 1.2. What is the ratio of the Expenses (% of total expenses) of East Asia (all income levels) in 2006 to that in 2011?
Make the answer very short. 1.08. What is the ratio of the Expenses (% of total expenses) of Belize in 2006 to that in 2011?
Ensure brevity in your answer.  0.94. What is the ratio of the Expenses (% of total expenses) of Georgia in 2006 to that in 2011?
Provide a short and direct response. 1.45. What is the ratio of the Expenses (% of total expenses) of Iceland in 2006 to that in 2011?
Offer a terse response. 1.17. What is the ratio of the Expenses (% of total expenses) of East Asia (all income levels) in 2006 to that in 2012?
Your answer should be compact. 1.03. What is the ratio of the Expenses (% of total expenses) in Belize in 2006 to that in 2012?
Offer a very short reply. 0.89. What is the ratio of the Expenses (% of total expenses) in Georgia in 2006 to that in 2012?
Provide a succinct answer. 1.52. What is the ratio of the Expenses (% of total expenses) of Iceland in 2006 to that in 2012?
Provide a succinct answer. 1.16. What is the ratio of the Expenses (% of total expenses) in East Asia (all income levels) in 2007 to that in 2008?
Make the answer very short. 1.02. What is the ratio of the Expenses (% of total expenses) in Belize in 2007 to that in 2008?
Provide a short and direct response. 0.87. What is the ratio of the Expenses (% of total expenses) in Georgia in 2007 to that in 2008?
Provide a short and direct response. 1.4. What is the ratio of the Expenses (% of total expenses) of Iceland in 2007 to that in 2008?
Provide a short and direct response. 1.4. What is the ratio of the Expenses (% of total expenses) in East Asia (all income levels) in 2007 to that in 2009?
Give a very brief answer. 1.35. What is the ratio of the Expenses (% of total expenses) of Belize in 2007 to that in 2009?
Provide a succinct answer. 0.87. What is the ratio of the Expenses (% of total expenses) of Georgia in 2007 to that in 2009?
Offer a very short reply. 2.01. What is the ratio of the Expenses (% of total expenses) in Iceland in 2007 to that in 2009?
Give a very brief answer. 1.09. What is the ratio of the Expenses (% of total expenses) in East Asia (all income levels) in 2007 to that in 2010?
Offer a terse response. 1.31. What is the ratio of the Expenses (% of total expenses) in Belize in 2007 to that in 2010?
Keep it short and to the point. 0.87. What is the ratio of the Expenses (% of total expenses) of Georgia in 2007 to that in 2010?
Provide a succinct answer. 2.37. What is the ratio of the Expenses (% of total expenses) of Iceland in 2007 to that in 2010?
Ensure brevity in your answer.  1.19. What is the ratio of the Expenses (% of total expenses) in East Asia (all income levels) in 2007 to that in 2011?
Give a very brief answer. 1.37. What is the ratio of the Expenses (% of total expenses) in Belize in 2007 to that in 2011?
Make the answer very short. 0.86. What is the ratio of the Expenses (% of total expenses) in Georgia in 2007 to that in 2011?
Offer a terse response. 2.29. What is the ratio of the Expenses (% of total expenses) of Iceland in 2007 to that in 2011?
Offer a terse response. 1.16. What is the ratio of the Expenses (% of total expenses) in East Asia (all income levels) in 2007 to that in 2012?
Keep it short and to the point. 1.31. What is the ratio of the Expenses (% of total expenses) of Belize in 2007 to that in 2012?
Give a very brief answer. 0.82. What is the ratio of the Expenses (% of total expenses) in Georgia in 2007 to that in 2012?
Your answer should be compact. 2.39. What is the ratio of the Expenses (% of total expenses) in Iceland in 2007 to that in 2012?
Your answer should be compact. 1.14. What is the ratio of the Expenses (% of total expenses) of East Asia (all income levels) in 2008 to that in 2009?
Your response must be concise. 1.33. What is the ratio of the Expenses (% of total expenses) in Belize in 2008 to that in 2009?
Keep it short and to the point. 0.99. What is the ratio of the Expenses (% of total expenses) of Georgia in 2008 to that in 2009?
Keep it short and to the point. 1.43. What is the ratio of the Expenses (% of total expenses) in Iceland in 2008 to that in 2009?
Give a very brief answer. 0.78. What is the ratio of the Expenses (% of total expenses) of East Asia (all income levels) in 2008 to that in 2010?
Your answer should be compact. 1.29. What is the ratio of the Expenses (% of total expenses) of Georgia in 2008 to that in 2010?
Keep it short and to the point. 1.68. What is the ratio of the Expenses (% of total expenses) in Iceland in 2008 to that in 2010?
Give a very brief answer. 0.84. What is the ratio of the Expenses (% of total expenses) in East Asia (all income levels) in 2008 to that in 2011?
Provide a short and direct response. 1.35. What is the ratio of the Expenses (% of total expenses) of Belize in 2008 to that in 2011?
Give a very brief answer. 0.98. What is the ratio of the Expenses (% of total expenses) in Georgia in 2008 to that in 2011?
Make the answer very short. 1.63. What is the ratio of the Expenses (% of total expenses) of Iceland in 2008 to that in 2011?
Your answer should be compact. 0.83. What is the ratio of the Expenses (% of total expenses) in East Asia (all income levels) in 2008 to that in 2012?
Your answer should be very brief. 1.28. What is the ratio of the Expenses (% of total expenses) in Belize in 2008 to that in 2012?
Make the answer very short. 0.94. What is the ratio of the Expenses (% of total expenses) in Georgia in 2008 to that in 2012?
Give a very brief answer. 1.7. What is the ratio of the Expenses (% of total expenses) in Iceland in 2008 to that in 2012?
Your answer should be very brief. 0.82. What is the ratio of the Expenses (% of total expenses) of East Asia (all income levels) in 2009 to that in 2010?
Your answer should be very brief. 0.97. What is the ratio of the Expenses (% of total expenses) in Belize in 2009 to that in 2010?
Your answer should be compact. 1.01. What is the ratio of the Expenses (% of total expenses) in Georgia in 2009 to that in 2010?
Make the answer very short. 1.18. What is the ratio of the Expenses (% of total expenses) in Iceland in 2009 to that in 2010?
Your response must be concise. 1.09. What is the ratio of the Expenses (% of total expenses) of East Asia (all income levels) in 2009 to that in 2011?
Provide a succinct answer. 1.01. What is the ratio of the Expenses (% of total expenses) in Georgia in 2009 to that in 2011?
Your answer should be very brief. 1.14. What is the ratio of the Expenses (% of total expenses) of Iceland in 2009 to that in 2011?
Provide a succinct answer. 1.06. What is the ratio of the Expenses (% of total expenses) of East Asia (all income levels) in 2009 to that in 2012?
Your answer should be compact. 0.97. What is the ratio of the Expenses (% of total expenses) in Belize in 2009 to that in 2012?
Make the answer very short. 0.94. What is the ratio of the Expenses (% of total expenses) in Georgia in 2009 to that in 2012?
Your answer should be compact. 1.19. What is the ratio of the Expenses (% of total expenses) in Iceland in 2009 to that in 2012?
Give a very brief answer. 1.05. What is the ratio of the Expenses (% of total expenses) of East Asia (all income levels) in 2010 to that in 2011?
Your answer should be very brief. 1.04. What is the ratio of the Expenses (% of total expenses) in Belize in 2010 to that in 2011?
Give a very brief answer. 0.98. What is the ratio of the Expenses (% of total expenses) of Georgia in 2010 to that in 2011?
Give a very brief answer. 0.97. What is the ratio of the Expenses (% of total expenses) of Iceland in 2010 to that in 2011?
Keep it short and to the point. 0.98. What is the ratio of the Expenses (% of total expenses) in East Asia (all income levels) in 2010 to that in 2012?
Keep it short and to the point. 0.99. What is the ratio of the Expenses (% of total expenses) in Belize in 2010 to that in 2012?
Keep it short and to the point. 0.94. What is the ratio of the Expenses (% of total expenses) of Georgia in 2010 to that in 2012?
Provide a short and direct response. 1.01. What is the ratio of the Expenses (% of total expenses) of Iceland in 2010 to that in 2012?
Provide a succinct answer. 0.97. What is the ratio of the Expenses (% of total expenses) of East Asia (all income levels) in 2011 to that in 2012?
Your response must be concise. 0.95. What is the ratio of the Expenses (% of total expenses) in Belize in 2011 to that in 2012?
Your response must be concise. 0.95. What is the ratio of the Expenses (% of total expenses) of Georgia in 2011 to that in 2012?
Offer a very short reply. 1.04. What is the ratio of the Expenses (% of total expenses) of Iceland in 2011 to that in 2012?
Give a very brief answer. 0.99. What is the difference between the highest and the second highest Expenses (% of total expenses) in East Asia (all income levels)?
Offer a very short reply. 0.51. What is the difference between the highest and the second highest Expenses (% of total expenses) in Belize?
Offer a terse response. 1.15. What is the difference between the highest and the second highest Expenses (% of total expenses) of Georgia?
Ensure brevity in your answer.  10.98. What is the difference between the highest and the second highest Expenses (% of total expenses) in Iceland?
Ensure brevity in your answer.  0.27. What is the difference between the highest and the lowest Expenses (% of total expenses) of East Asia (all income levels)?
Offer a terse response. 7.19. What is the difference between the highest and the lowest Expenses (% of total expenses) in Belize?
Offer a terse response. 4.54. What is the difference between the highest and the lowest Expenses (% of total expenses) of Georgia?
Ensure brevity in your answer.  22.17. What is the difference between the highest and the lowest Expenses (% of total expenses) in Iceland?
Ensure brevity in your answer.  7.22. 